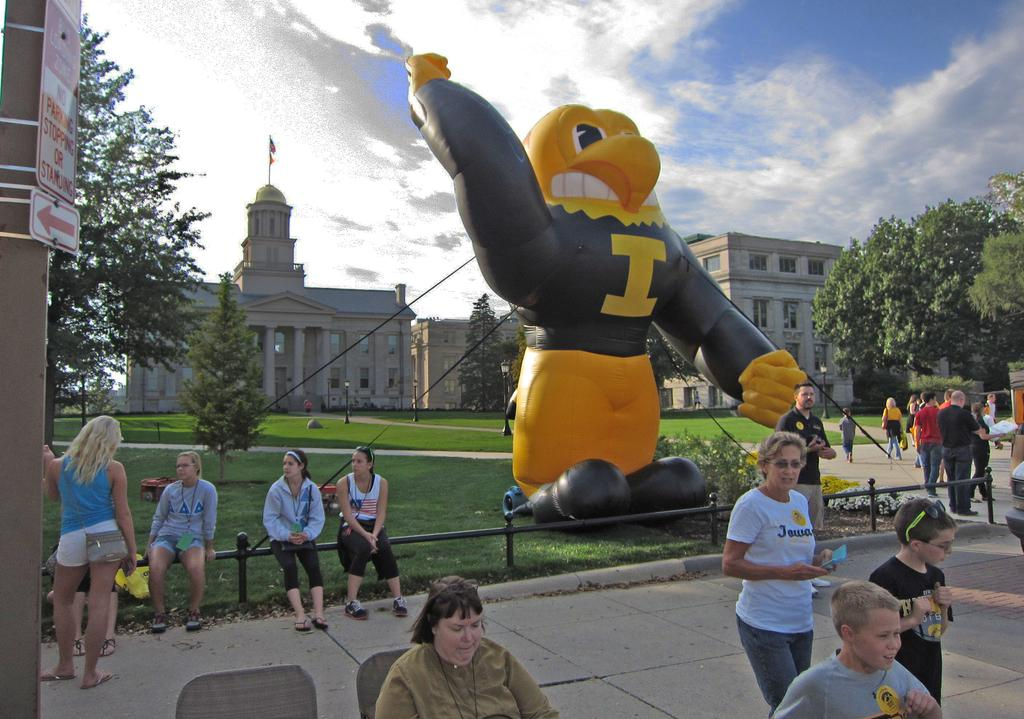Provide a one-sentence caption for the provided image. Group of people near a balloon of a mascot that has the letter "I" on it. 